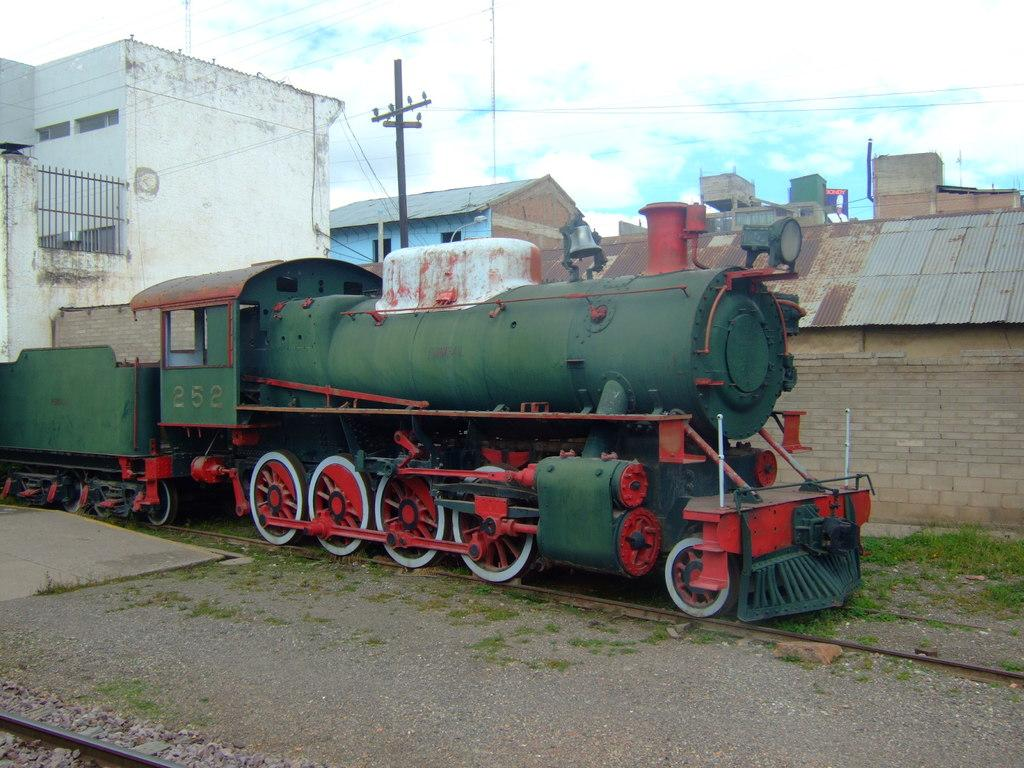What is the main subject in the foreground of the image? There is a train in the foreground of the image. What is located behind the train? There is a wall behind the train. What can be seen in the distance in the image? There are many houses and buildings in the background of the image. How many sticks are being used to build the fifth house in the image? There are no sticks or houses being built in the image; it features a train, a wall, and houses and buildings in the background. 